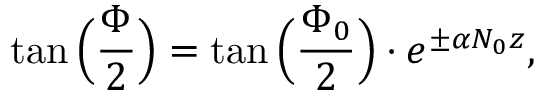Convert formula to latex. <formula><loc_0><loc_0><loc_500><loc_500>\tan \left ( \frac { \Phi } { 2 } \right ) = \tan \left ( \frac { \Phi _ { 0 } } { 2 } \right ) \cdot e ^ { \pm \alpha N _ { 0 } z } ,</formula> 